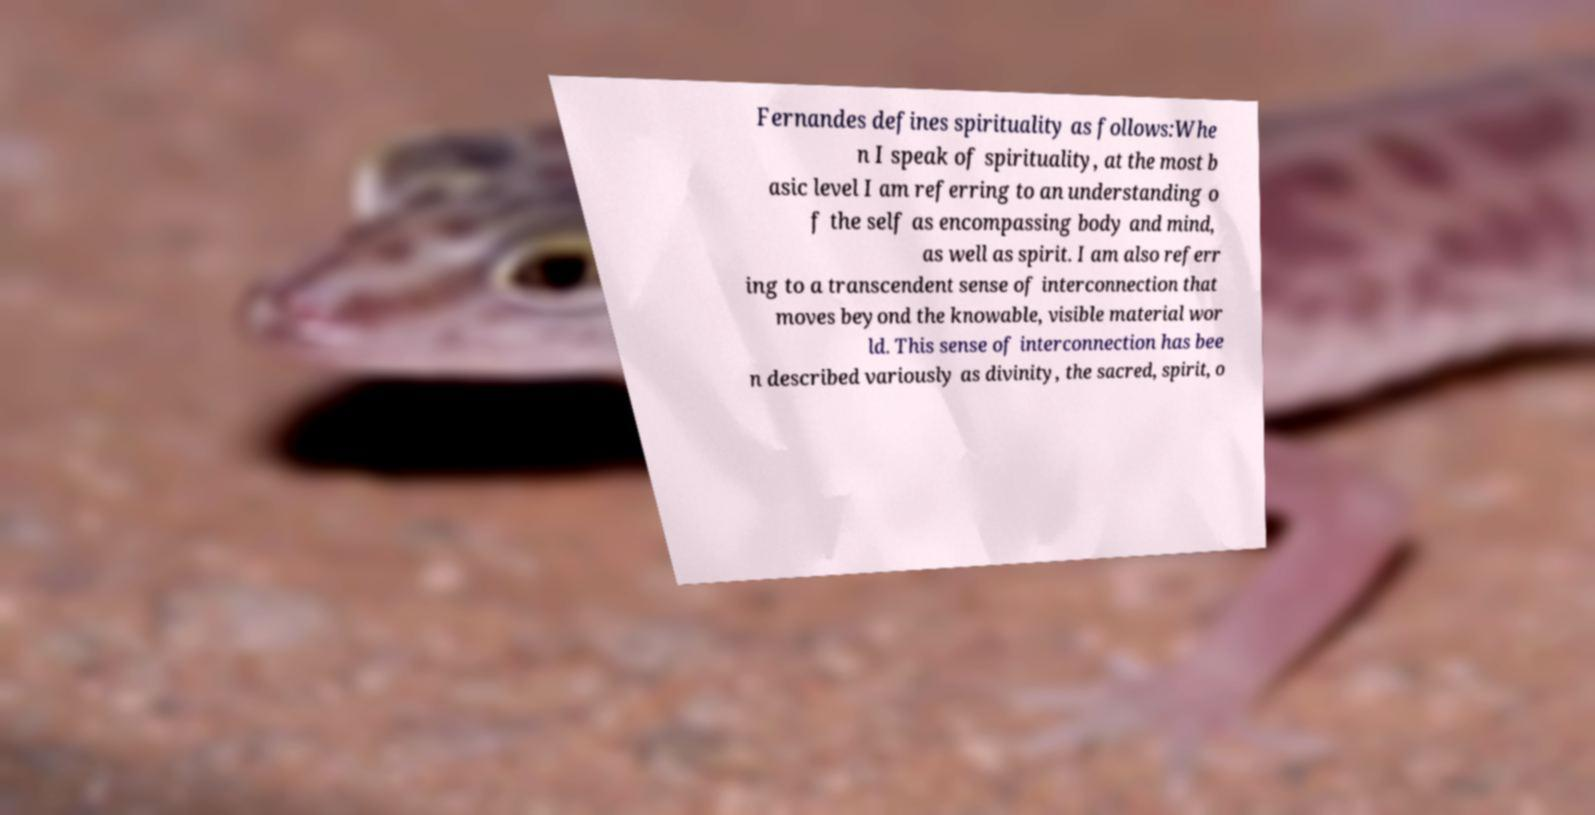For documentation purposes, I need the text within this image transcribed. Could you provide that? Fernandes defines spirituality as follows:Whe n I speak of spirituality, at the most b asic level I am referring to an understanding o f the self as encompassing body and mind, as well as spirit. I am also referr ing to a transcendent sense of interconnection that moves beyond the knowable, visible material wor ld. This sense of interconnection has bee n described variously as divinity, the sacred, spirit, o 